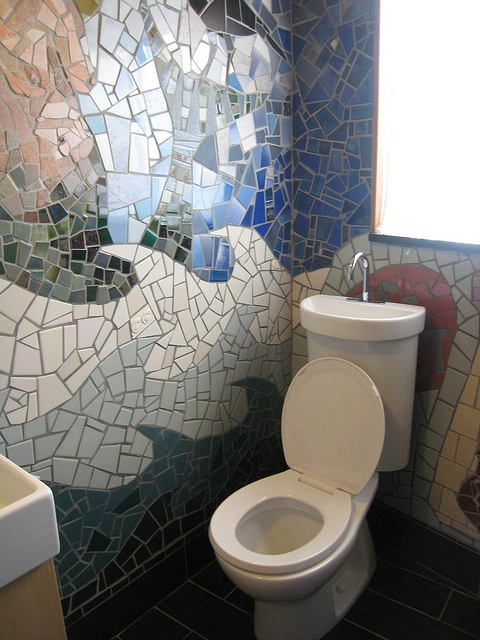Describe the objects in this image and their specific colors. I can see toilet in tan, gray, and black tones, sink in tan, gray, and lightgray tones, and sink in tan, lightgray, darkgray, and gray tones in this image. 